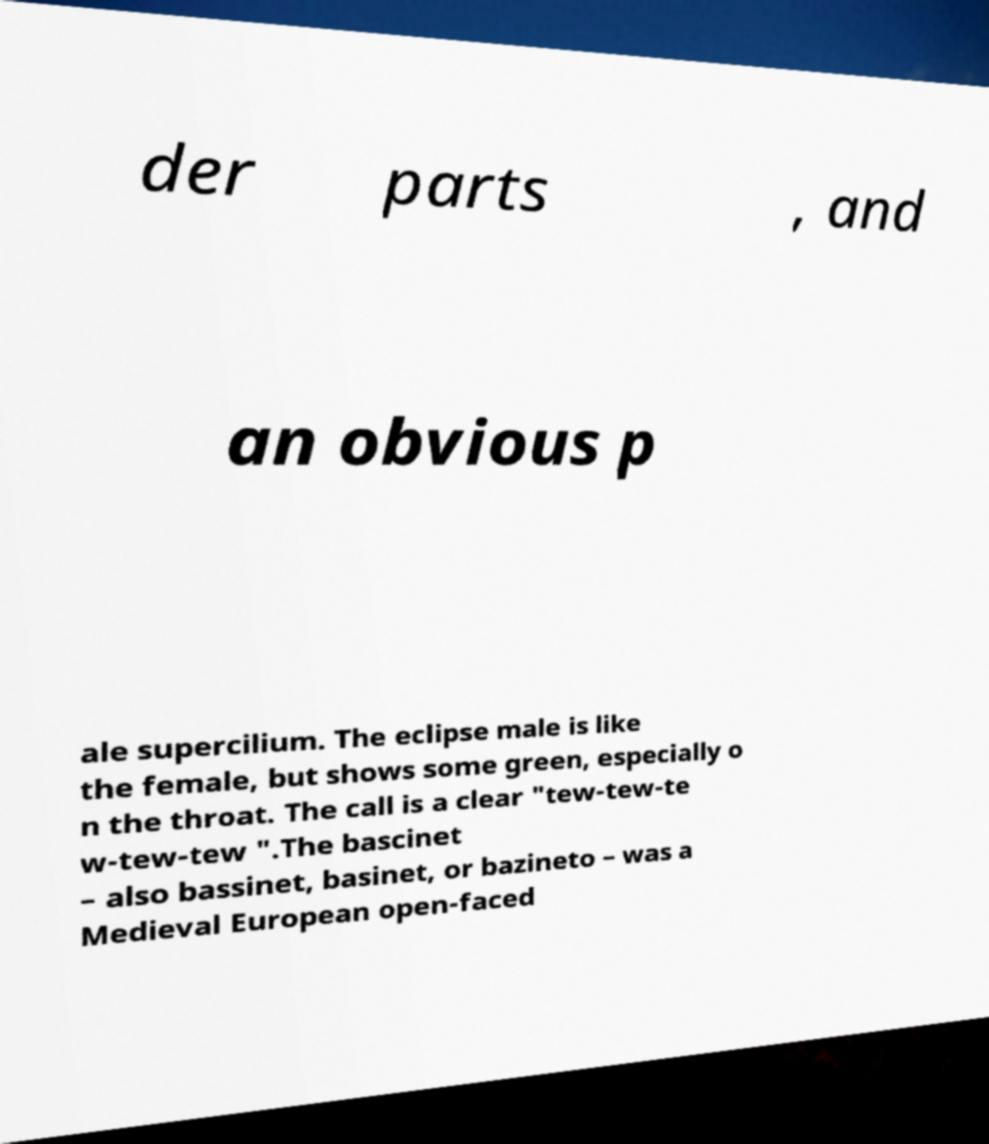I need the written content from this picture converted into text. Can you do that? der parts , and an obvious p ale supercilium. The eclipse male is like the female, but shows some green, especially o n the throat. The call is a clear "tew-tew-te w-tew-tew ".The bascinet – also bassinet, basinet, or bazineto – was a Medieval European open-faced 